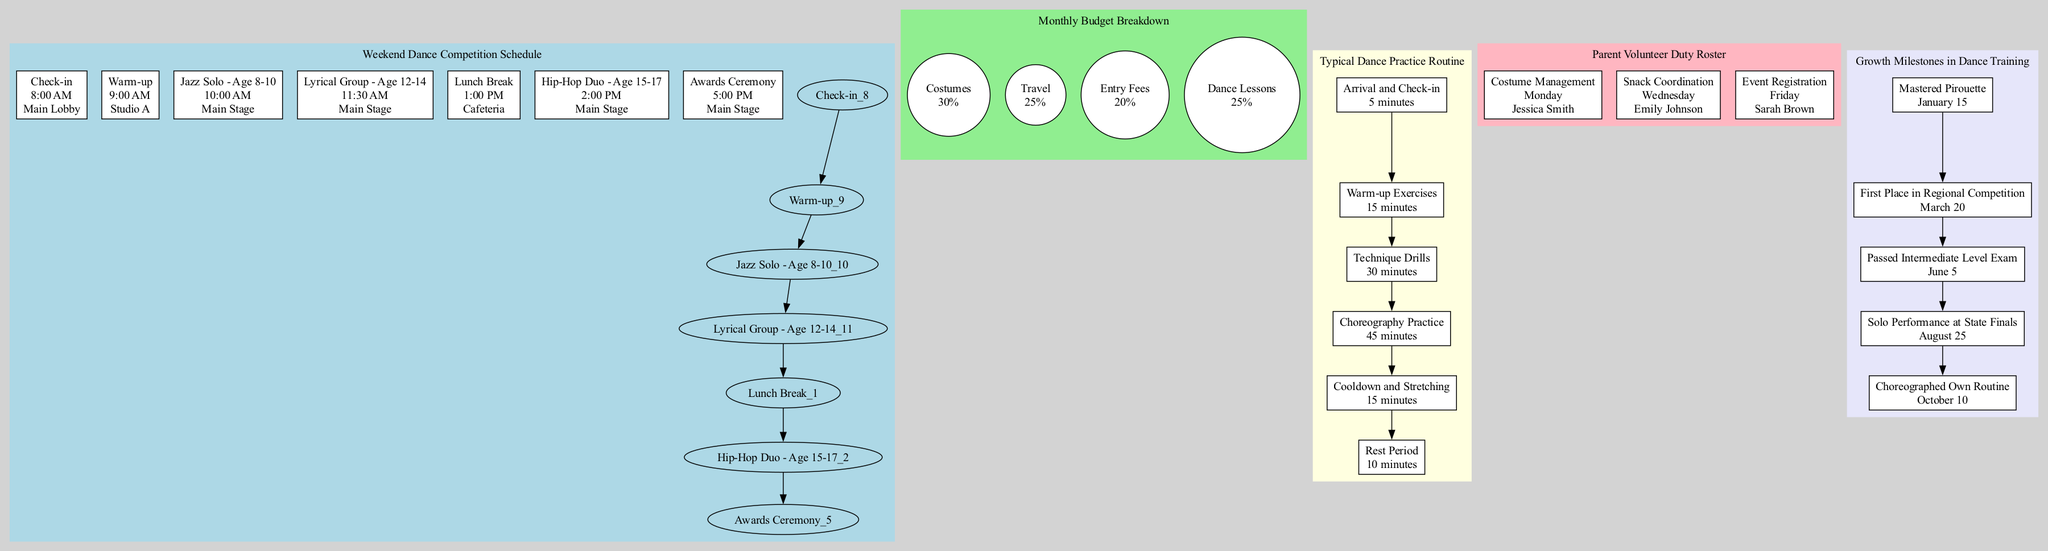What time is the Awards Ceremony scheduled? The diagram shows the event "Awards Ceremony" with a time next to it. The time listed is 5:00 PM, which indicates when this event will take place.
Answer: 5:00 PM What is the total percentage for Dance Lessons and Travel in the budget pie chart? Adding the percentages for "Dance Lessons" (25%) and "Travel" (25%) gives a total of 50%. This combines two key budget categories to reflect a portion of the overall expenses.
Answer: 50% How many warm-up exercises are listed in the practice routine? The diagram indicates the "Warm-up Exercises" step, which is the second step in the typical dance practice routine. There is only one warm-up step listed, so the answer is one.
Answer: One Who volunteers for Snack Coordination? In the Parent Volunteer Duty Roster section, the volunteer listed for "Snack Coordination" on "Wednesday" is "Emily Johnson". This information can be found in the corresponding box for that specific task.
Answer: Emily Johnson Which milestone was achieved on March 20? The diagram provides a timeline with milestones and corresponding dates. By checking the date next to "First Place in Regional Competition," which is identified as occurring on March 20, we can determine the milestone.
Answer: First Place in Regional Competition What is the location for the Jazz Solo event? The diagram specifies the "Jazz Solo - Age 8-10" event, and upon checking the details, the location indicated is the "Main Stage". This information can be found below the event name on the schedule.
Answer: Main Stage How many parent volunteer tasks are scheduled for the week? The Parent Volunteer Duty Roster lists three specific task entries: "Costume Management," "Snack Coordination," and "Event Registration." Counting these tasks reveals a total of three scheduled tasks.
Answer: Three What activities occur before the Cooldown and Stretching in the dance practice routine? By following the flowchart in the practice routine, the activities listed before "Cooldown and Stretching" are "Arrival and Check-in," "Warm-up Exercises," and "Technique Drills." This indicates the sequence leading up to that step in the routine.
Answer: Arrival and Check-in, Warm-up Exercises, Technique Drills What percentage of the monthly budget is allocated to Entry Fees? The diagram shows that the "Entry Fees" category has a specified percentage, which is 20%. This information is part of the budget breakdown section and directly answers the query.
Answer: 20% 